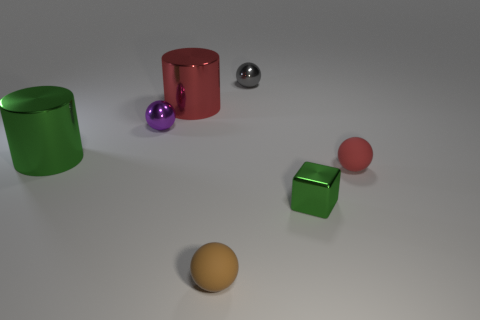What is the size of the red cylinder?
Offer a very short reply. Large. What is the color of the big object to the left of the metallic ball that is to the left of the tiny gray object?
Offer a very short reply. Green. How many things are behind the green block and on the right side of the tiny gray sphere?
Provide a succinct answer. 1. Is the number of brown matte spheres greater than the number of big yellow rubber cubes?
Your answer should be compact. Yes. What material is the tiny purple sphere?
Provide a succinct answer. Metal. How many tiny blocks are on the left side of the metallic object in front of the tiny red rubber ball?
Make the answer very short. 0. Does the cube have the same color as the big object that is on the left side of the tiny purple thing?
Your answer should be compact. Yes. There is a cube that is the same size as the gray thing; what is its color?
Provide a succinct answer. Green. Are there any small red rubber objects that have the same shape as the brown rubber object?
Your answer should be very brief. Yes. Are there fewer green metal objects than large red metallic blocks?
Give a very brief answer. No. 